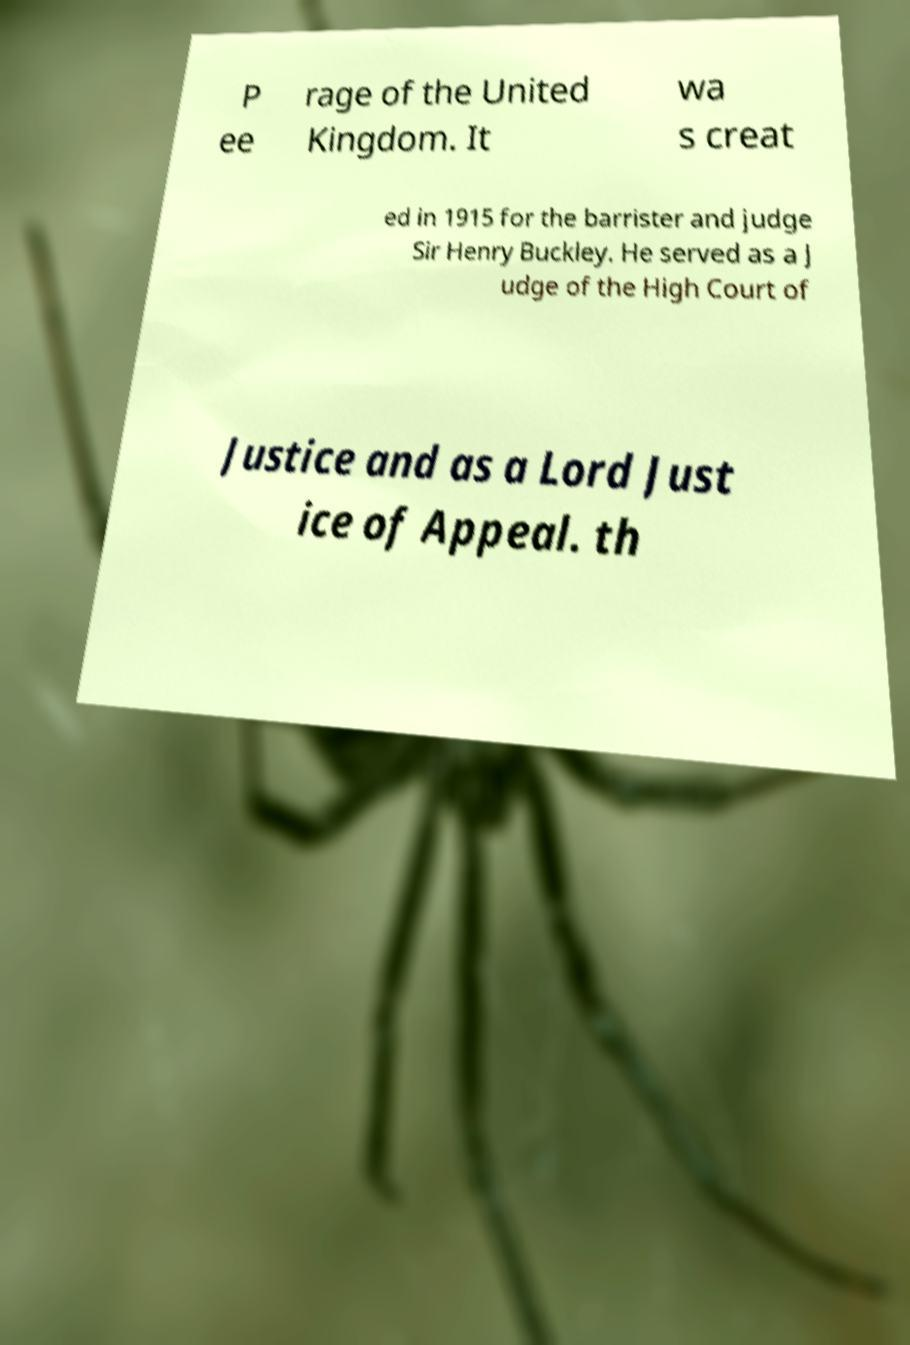Please read and relay the text visible in this image. What does it say? P ee rage of the United Kingdom. It wa s creat ed in 1915 for the barrister and judge Sir Henry Buckley. He served as a J udge of the High Court of Justice and as a Lord Just ice of Appeal. th 